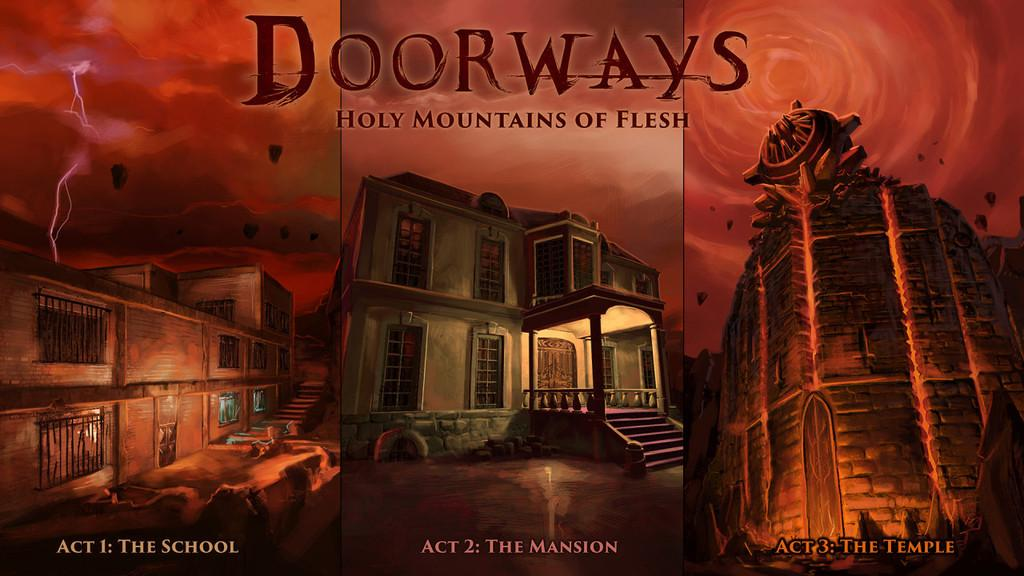<image>
Relay a brief, clear account of the picture shown. the word doorways is above the building outside 